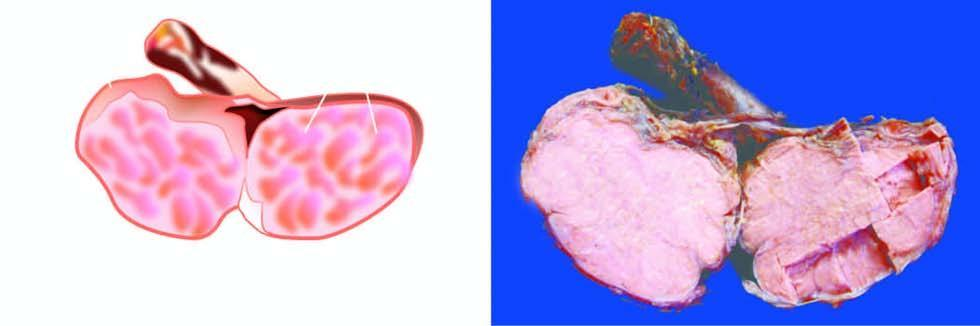s mall enlarged but without distorting its contour?
Answer the question using a single word or phrase. No 